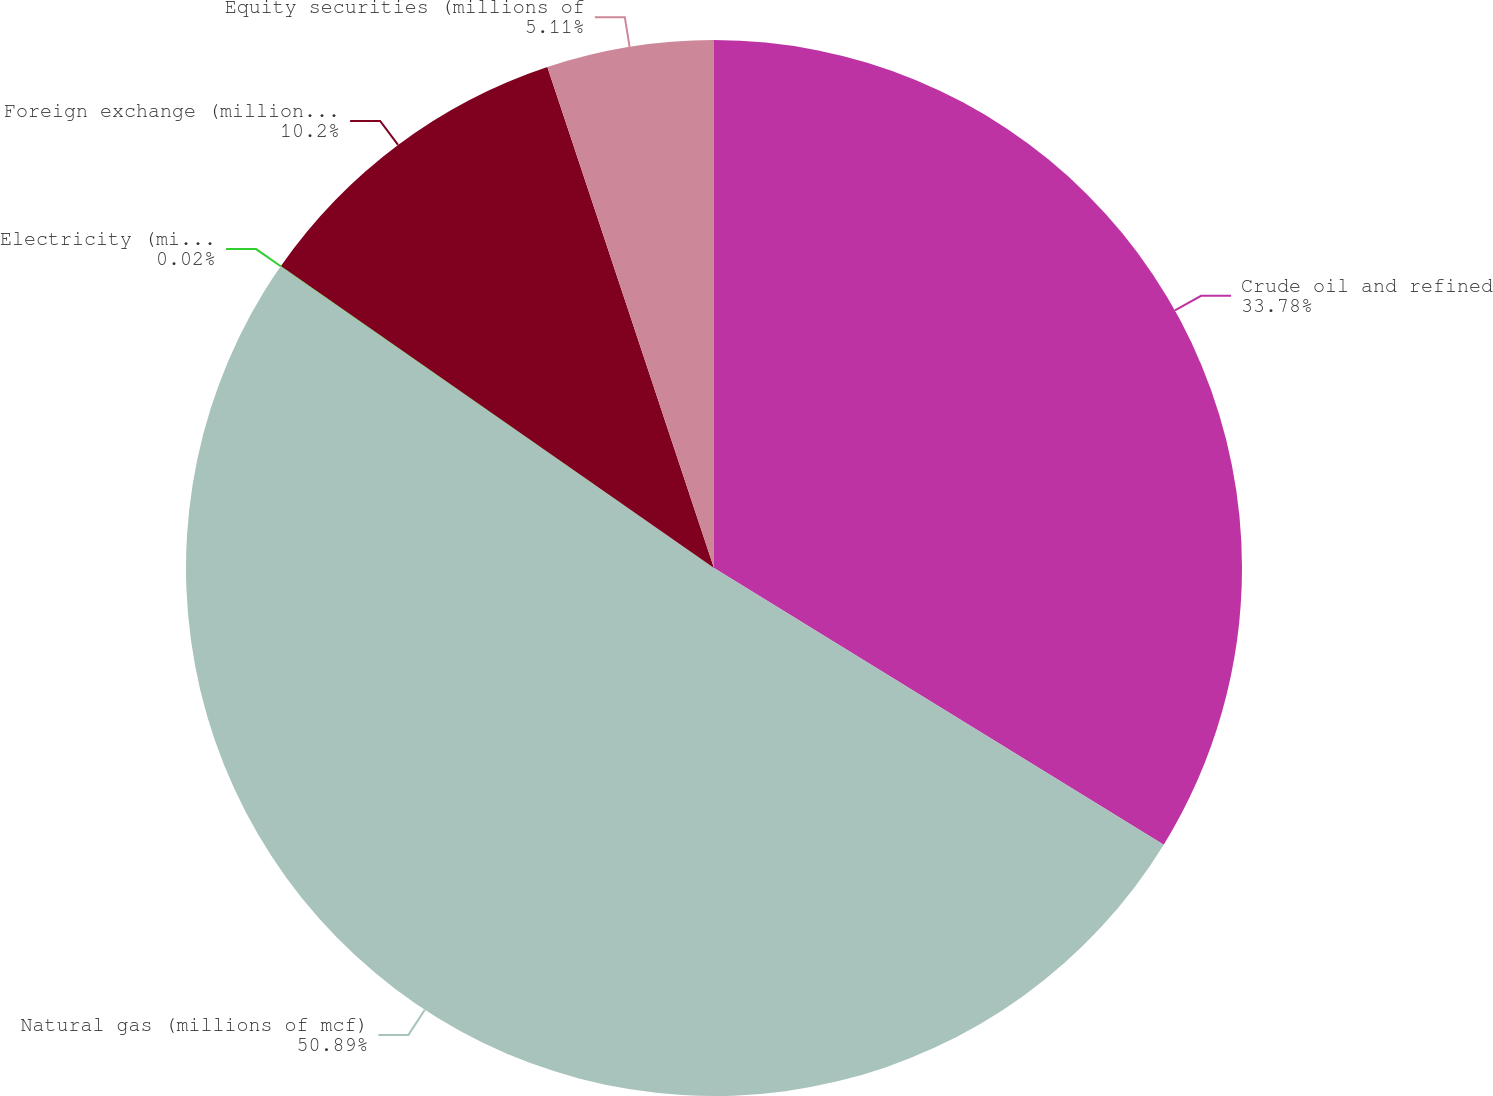Convert chart. <chart><loc_0><loc_0><loc_500><loc_500><pie_chart><fcel>Crude oil and refined<fcel>Natural gas (millions of mcf)<fcel>Electricity (millions of<fcel>Foreign exchange (millions of<fcel>Equity securities (millions of<nl><fcel>33.78%<fcel>50.9%<fcel>0.02%<fcel>10.2%<fcel>5.11%<nl></chart> 